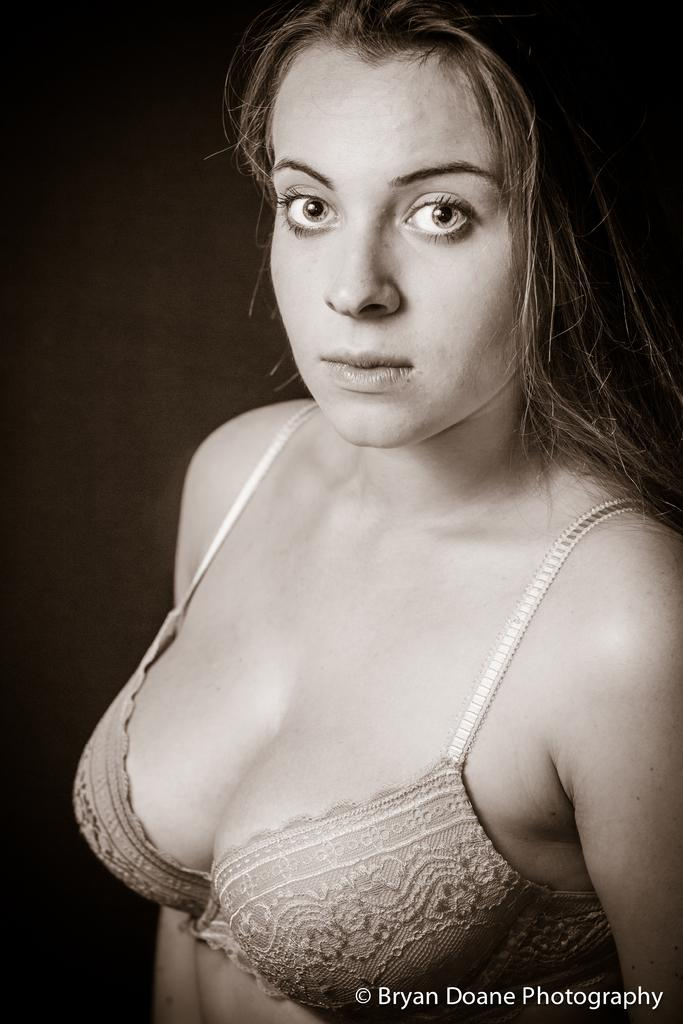What is the color scheme of the image? The image is black and white. Who or what is the main subject in the image? There is a woman in the image. Are there any words or letters in the image? Yes, there is text in the image. What color is the background of the image? The background is black. What is the name of the baby in the crib in the image? There is no baby or crib present in the image. 